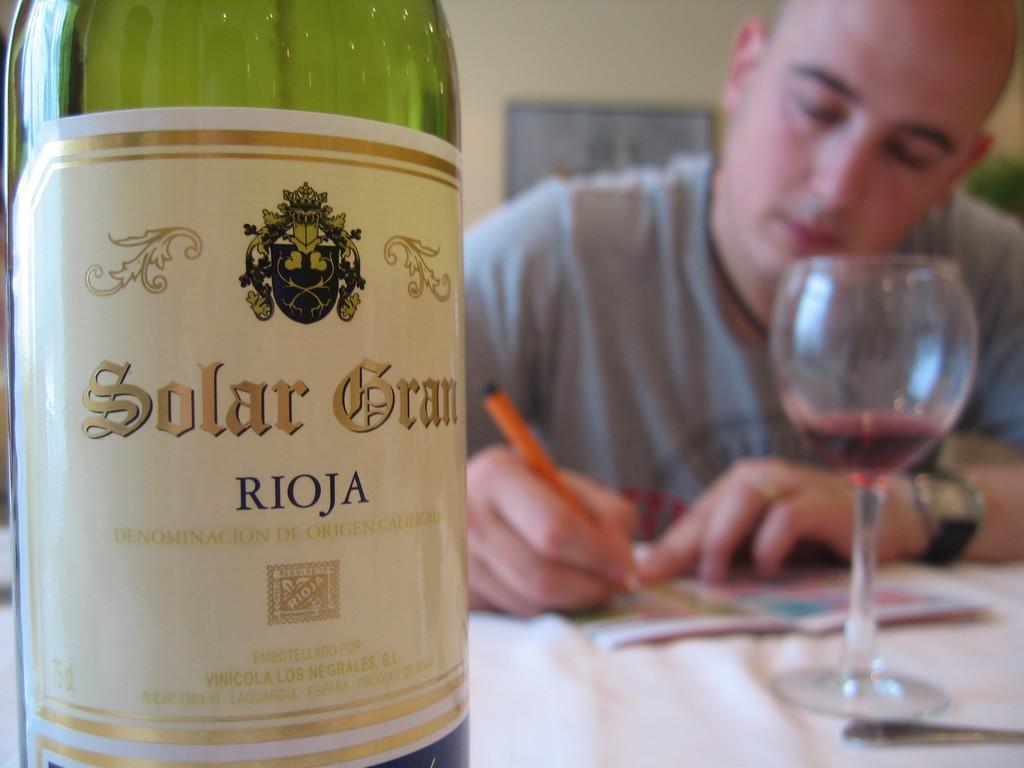Can you describe this image briefly? In the background of the image a man is sitting and writing something, he is wearing a gray t-shirt. On the table there is a book and a glass. In the foreground there is a wine bottle. In the middle of the background on the wall there is a frame. 